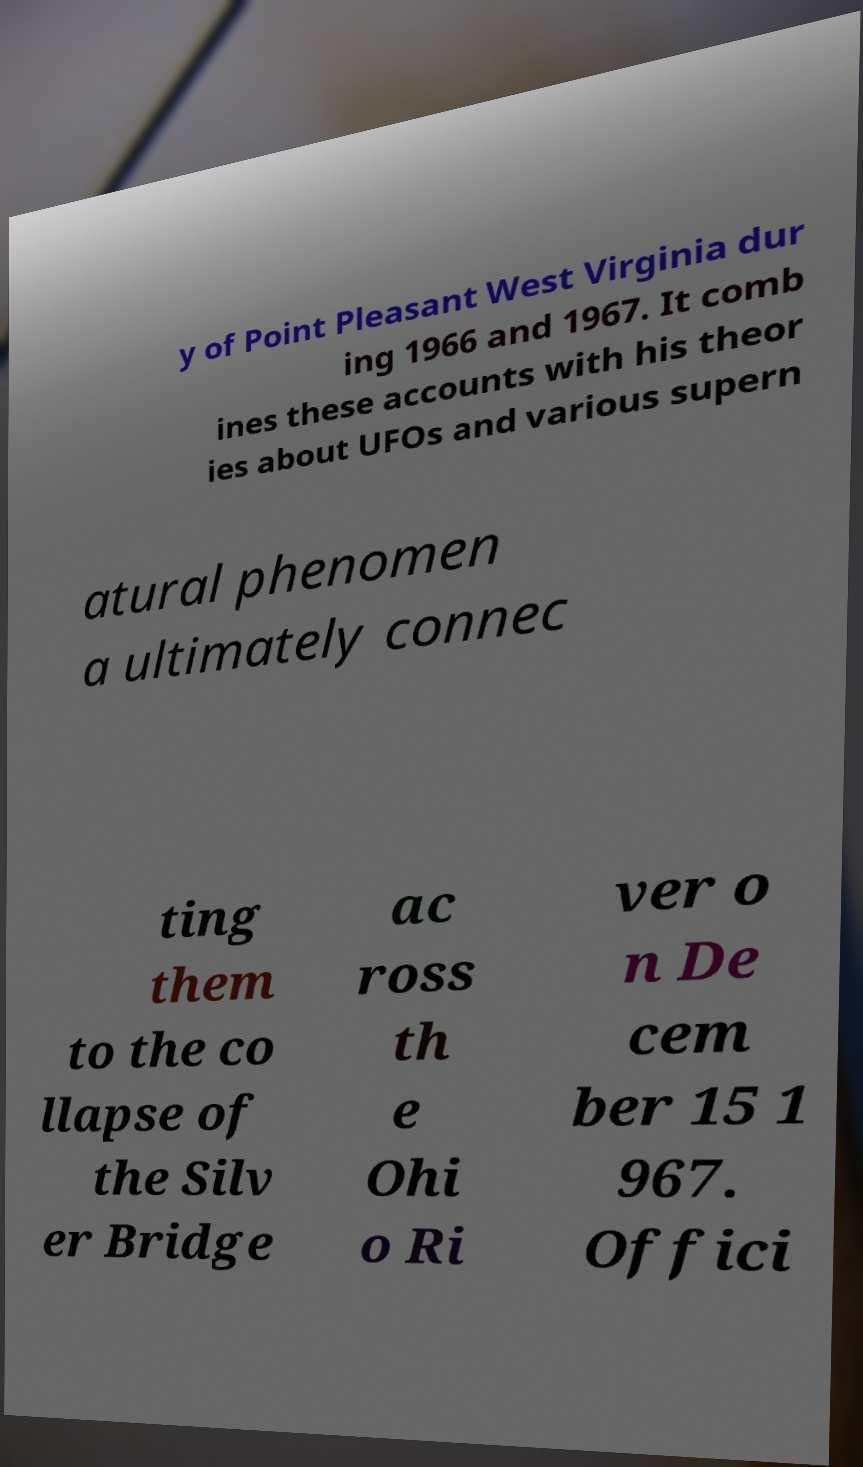Please read and relay the text visible in this image. What does it say? y of Point Pleasant West Virginia dur ing 1966 and 1967. It comb ines these accounts with his theor ies about UFOs and various supern atural phenomen a ultimately connec ting them to the co llapse of the Silv er Bridge ac ross th e Ohi o Ri ver o n De cem ber 15 1 967. Offici 